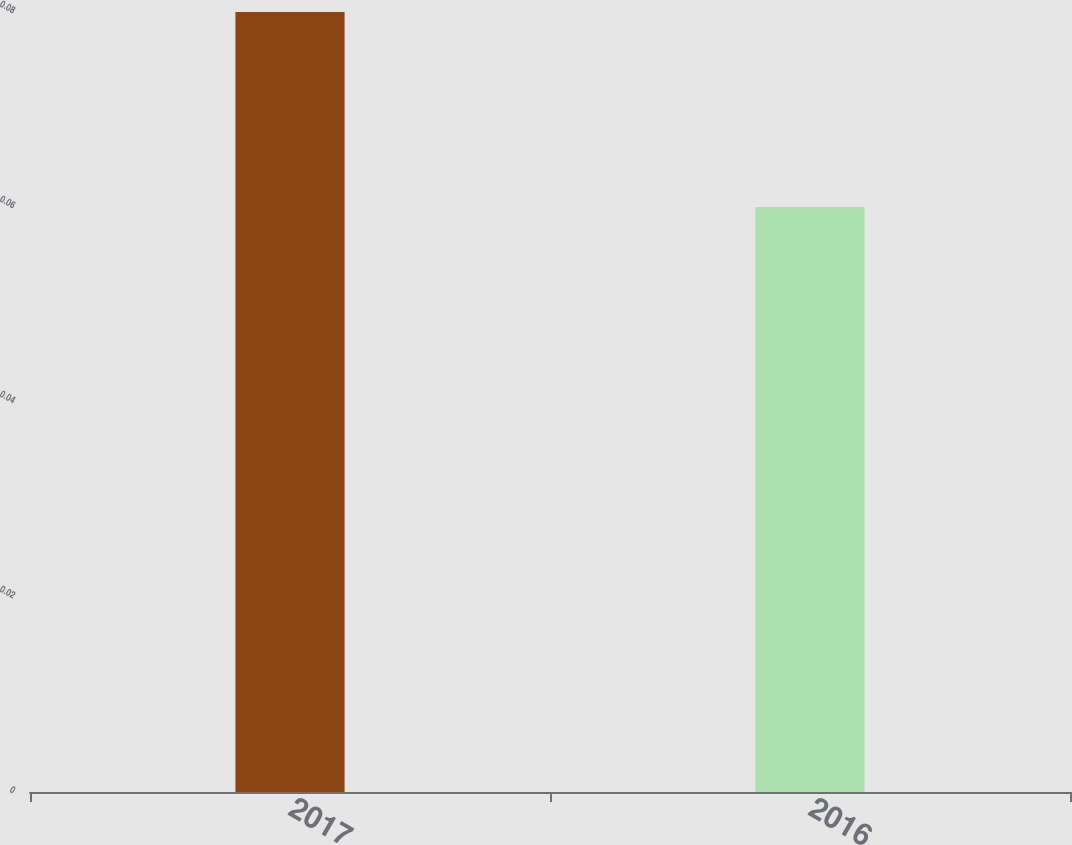Convert chart. <chart><loc_0><loc_0><loc_500><loc_500><bar_chart><fcel>2017<fcel>2016<nl><fcel>0.08<fcel>0.06<nl></chart> 